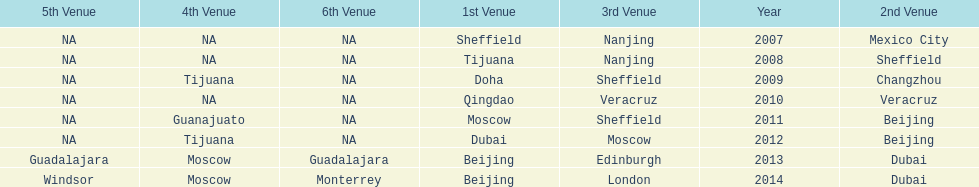In list of venues, how many years was beijing above moscow (1st venue is above 2nd venue, etc)? 3. 